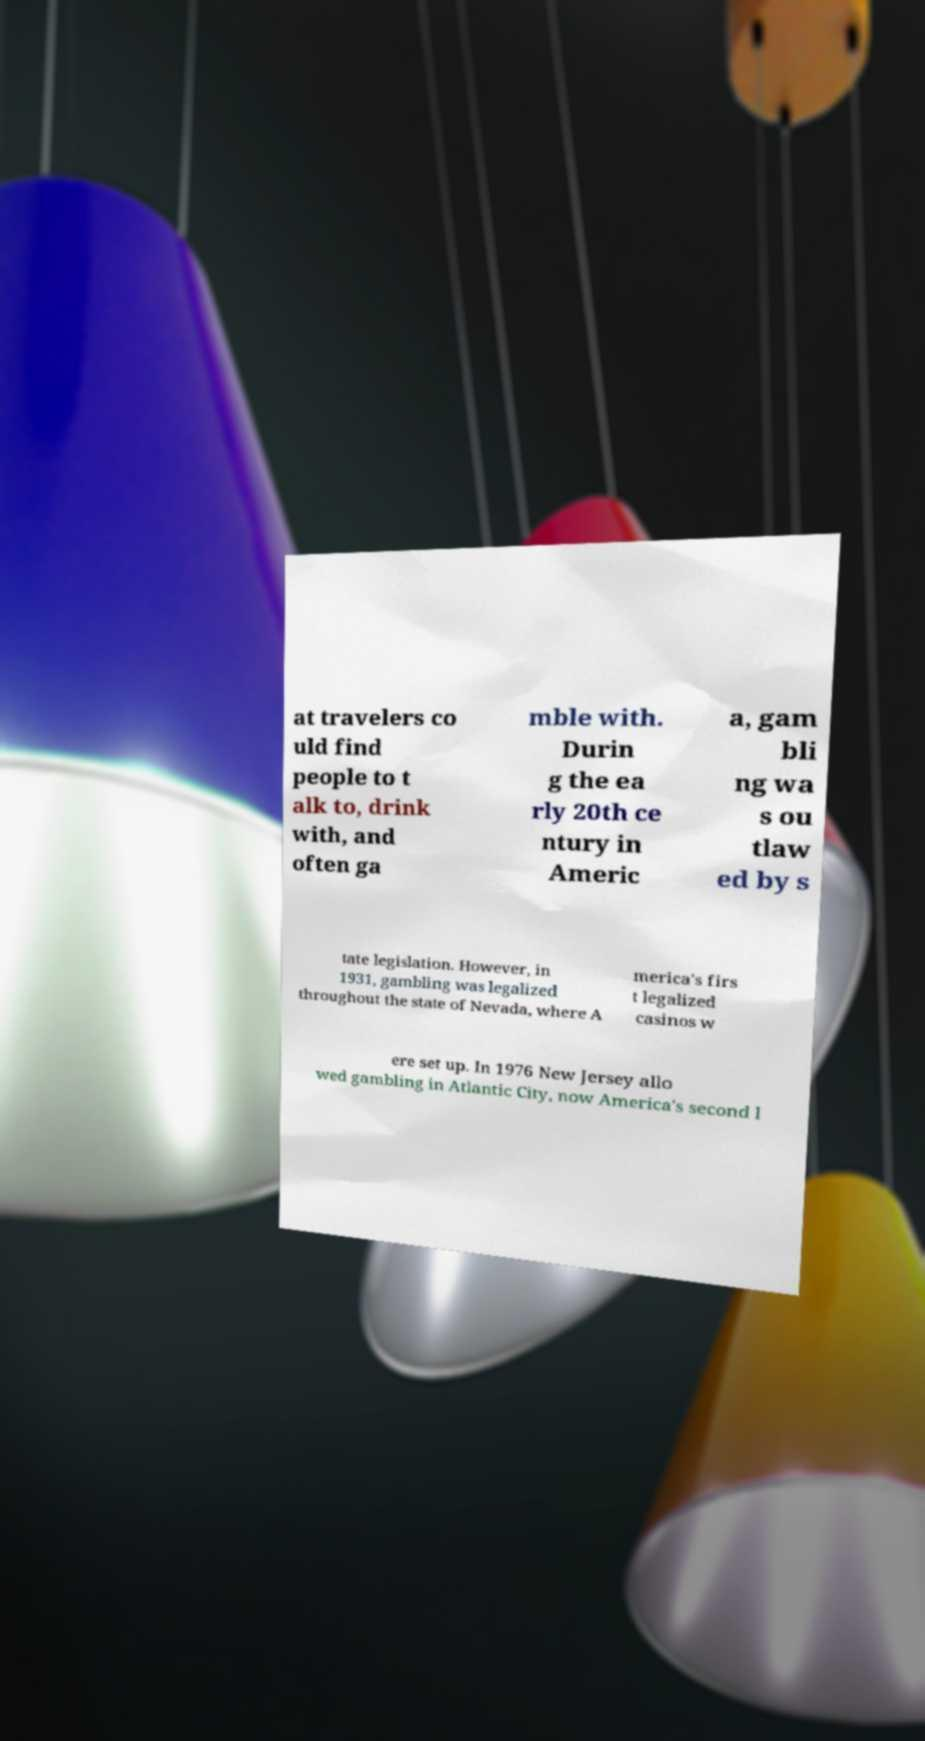What messages or text are displayed in this image? I need them in a readable, typed format. at travelers co uld find people to t alk to, drink with, and often ga mble with. Durin g the ea rly 20th ce ntury in Americ a, gam bli ng wa s ou tlaw ed by s tate legislation. However, in 1931, gambling was legalized throughout the state of Nevada, where A merica's firs t legalized casinos w ere set up. In 1976 New Jersey allo wed gambling in Atlantic City, now America's second l 